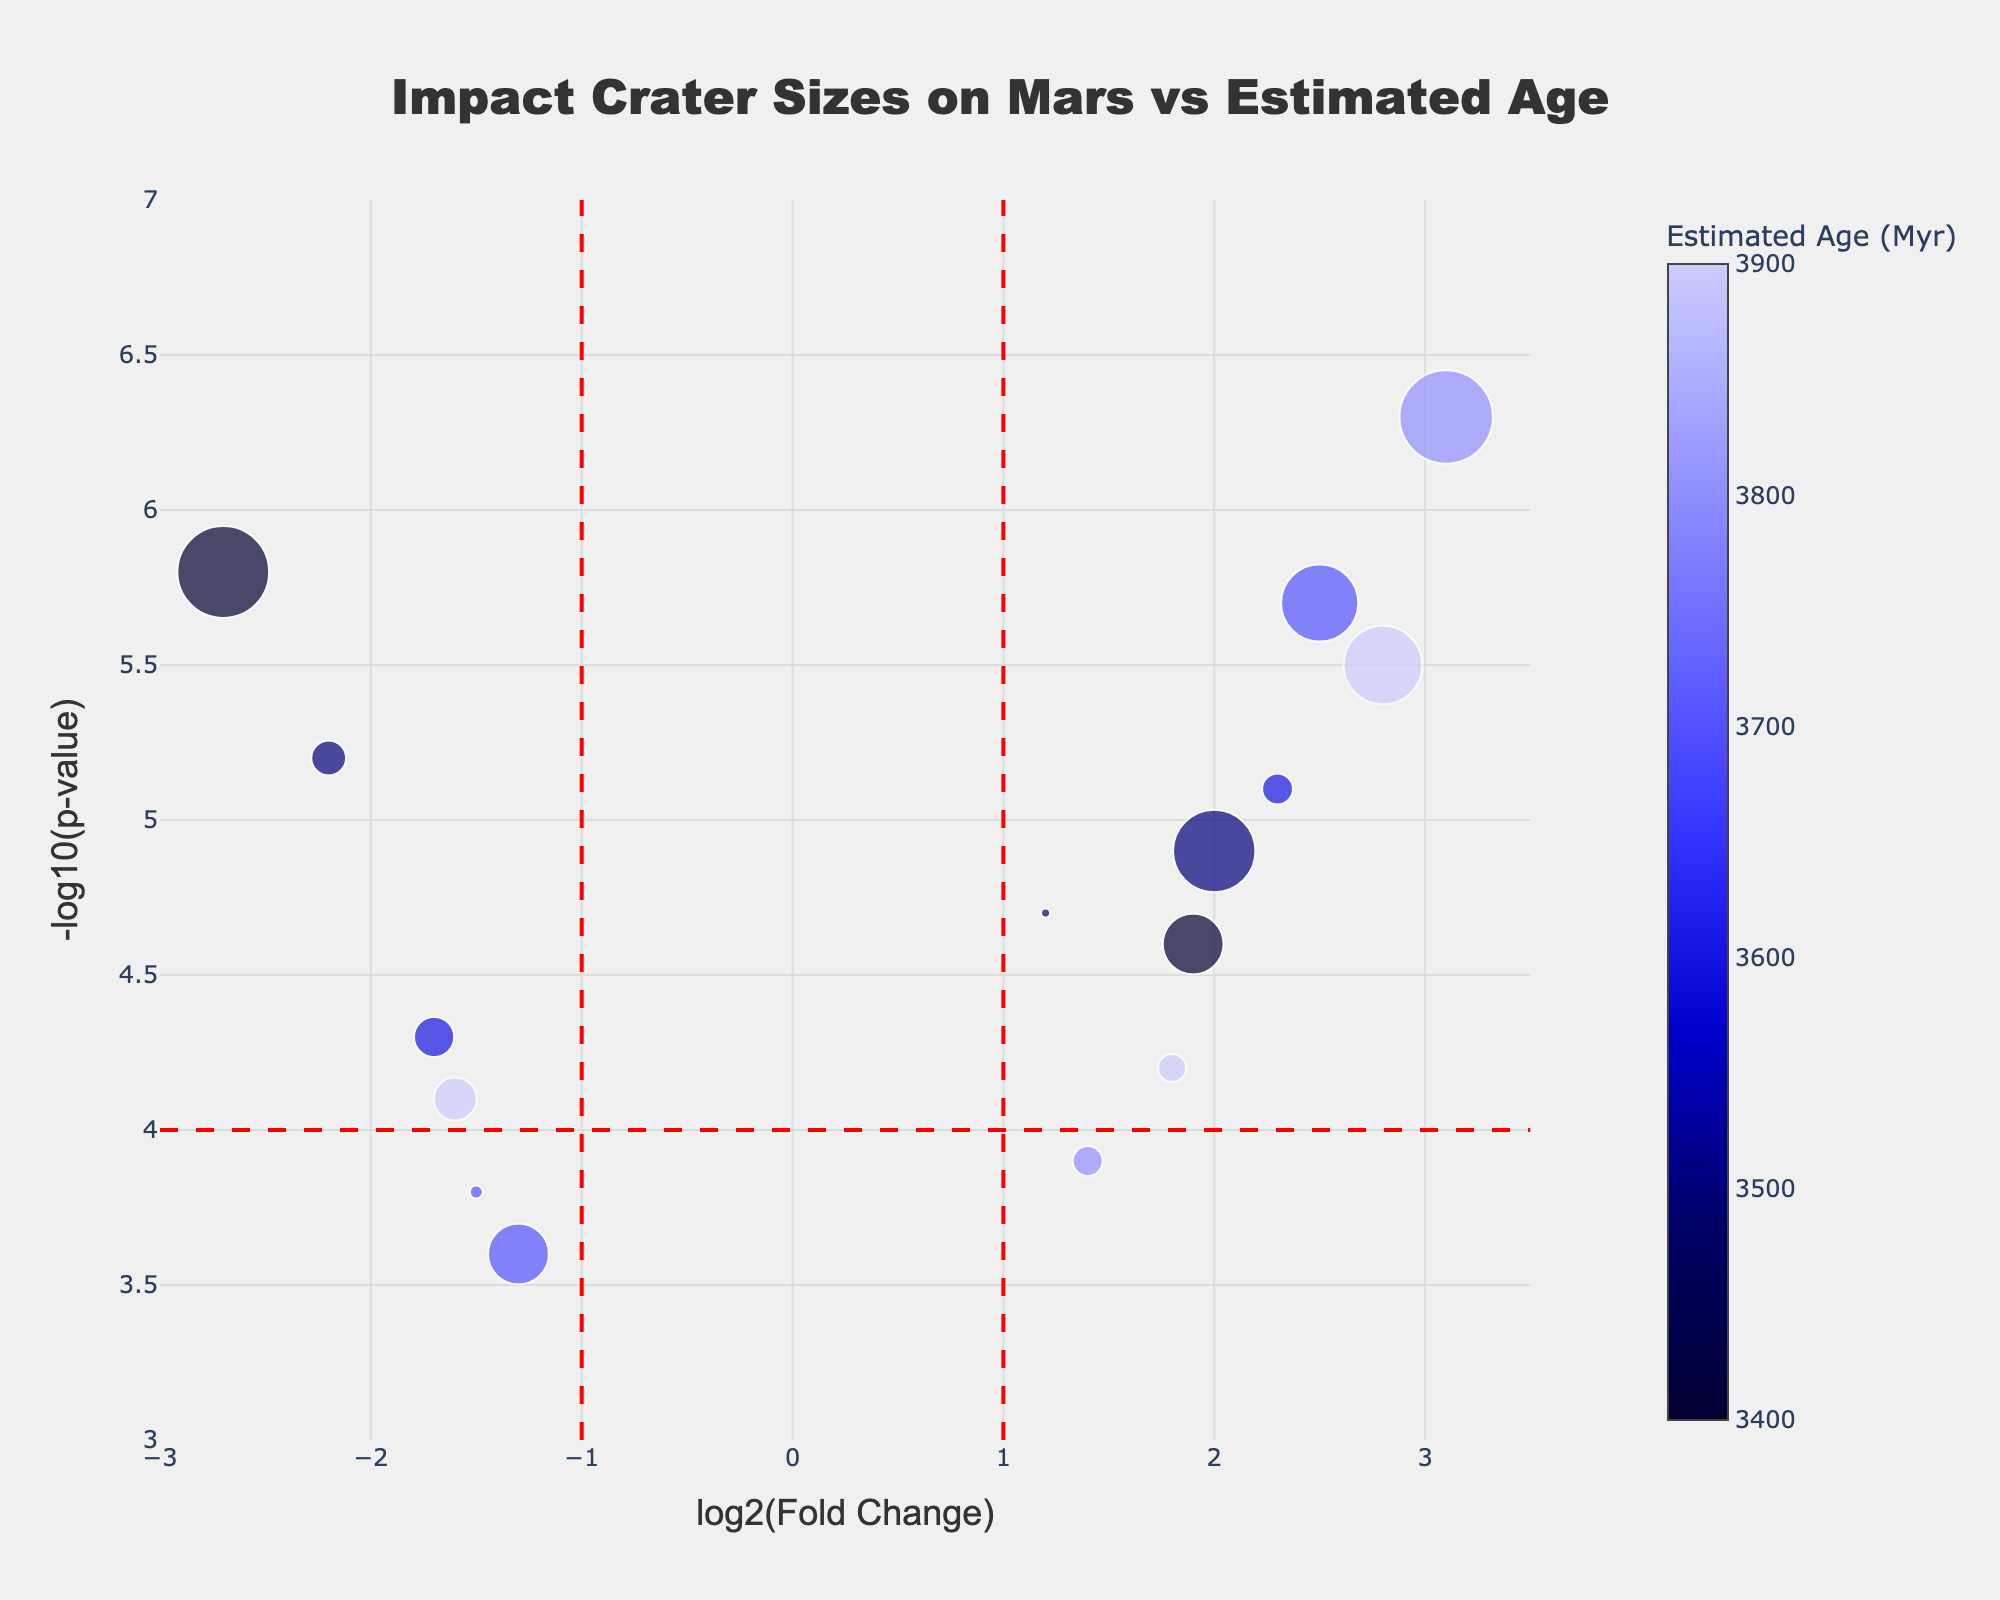What is the title of the figure? The title of the figure is generally located at the top center.
Answer: Impact Crater Sizes on Mars vs Estimated Age What does the x-axis represent? The x-axis label describes what it represents.
Answer: log2(Fold Change) What does the y-axis represent? The y-axis label describes what it represents.
Answer: -log10(p-value) How many craters have a diameter larger than 400 km? Identify the data points associated with craters having a diameter larger than 400 km: Huygens, Schiaparelli, Cassini, and Antoniadi.
Answer: 4 Which crater has the highest -log10(p-value)? The highest -log10(p-value) is the point positioned highest on the y-axis.
Answer: Huygens Which crater has the lowest log2(Fold Change)? The lowest log2(Fold Change) is the point farthest to the left on the x-axis.
Answer: Schiaparelli What is the estimated age range of the craters? Identify the minimum and maximum values from the color bar representing ages.
Answer: 3400 to 3900 Myr How many craters have a log2(Fold Change) greater than 1? Count all data points, i.e., craters, which lie to the right of the vertical threshold line at log2(Fold Change) = 1.
Answer: 7 What is the age of the crater with a log2(Fold Change) of approximately 2.3? Find the crater with log2(Fold Change) = 2.3 and check its corresponding estimated age from the hover information or color scale.
Answer: 3600 Myr (Gale) What craters fall into significantly upregulated and significantly downregulated categories? Identify craters in regions of significant upregulation (log2(Fold Change) > 1 and -log10(p-value) > 4) and significant downregulation (log2(Fold Change) < -1 and -log10(p-value) > 4).
Answer: Upregulated: Holden, Gale, Huygens, Antoniadi, Tikhonravov; Downregulated: Schiaparelli, Terby 